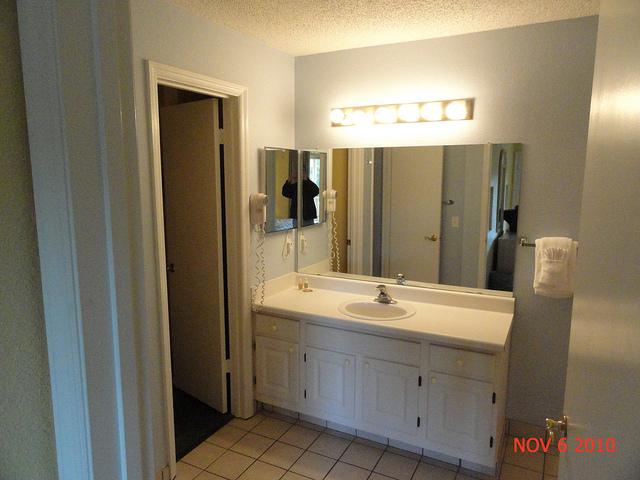What is the source of light in these rooms?
Answer briefly. Light bulbs. Is food prepared in this room?
Give a very brief answer. No. Would this be considered tidy?
Answer briefly. Yes. What room is this?
Keep it brief. Bathroom. Why is there a hair dryer on the wall?
Keep it brief. Yes. 